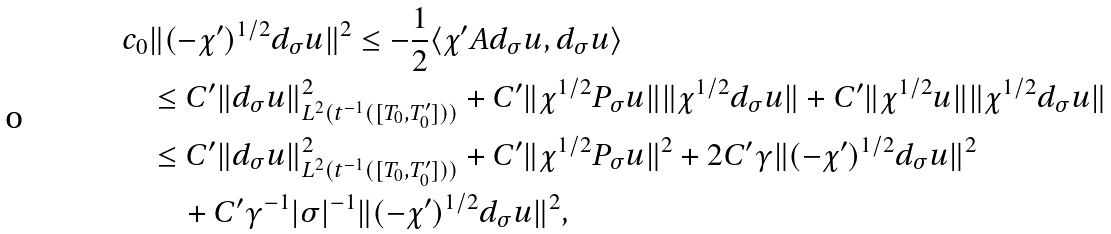Convert formula to latex. <formula><loc_0><loc_0><loc_500><loc_500>c _ { 0 } & \| ( - \chi ^ { \prime } ) ^ { 1 / 2 } d _ { \sigma } u \| ^ { 2 } \leq - \frac { 1 } { 2 } \langle \chi ^ { \prime } A d _ { \sigma } u , d _ { \sigma } u \rangle \\ & \leq C ^ { \prime } \| d _ { \sigma } u \| ^ { 2 } _ { L ^ { 2 } ( t ^ { - 1 } ( [ T _ { 0 } , T ^ { \prime } _ { 0 } ] ) ) } + C ^ { \prime } \| \chi ^ { 1 / 2 } P _ { \sigma } u \| \| \chi ^ { 1 / 2 } d _ { \sigma } u \| + C ^ { \prime } \| \chi ^ { 1 / 2 } u \| \| \chi ^ { 1 / 2 } d _ { \sigma } u \| \\ & \leq C ^ { \prime } \| d _ { \sigma } u \| ^ { 2 } _ { L ^ { 2 } ( t ^ { - 1 } ( [ T _ { 0 } , T ^ { \prime } _ { 0 } ] ) ) } + C ^ { \prime } \| \chi ^ { 1 / 2 } P _ { \sigma } u \| ^ { 2 } + 2 C ^ { \prime } \gamma \| ( - \chi ^ { \prime } ) ^ { 1 / 2 } d _ { \sigma } u \| ^ { 2 } \\ & \quad + C ^ { \prime } \gamma ^ { - 1 } | \sigma | ^ { - 1 } \| ( - \chi ^ { \prime } ) ^ { 1 / 2 } d _ { \sigma } u \| ^ { 2 } ,</formula> 